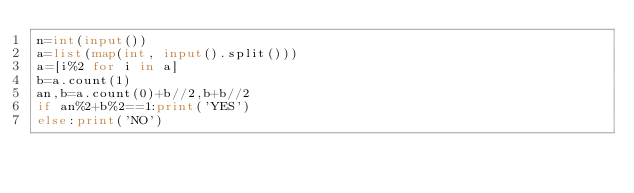<code> <loc_0><loc_0><loc_500><loc_500><_Python_>n=int(input())
a=list(map(int, input().split()))
a=[i%2 for i in a]
b=a.count(1)
an,b=a.count(0)+b//2,b+b//2
if an%2+b%2==1:print('YES')
else:print('NO')</code> 